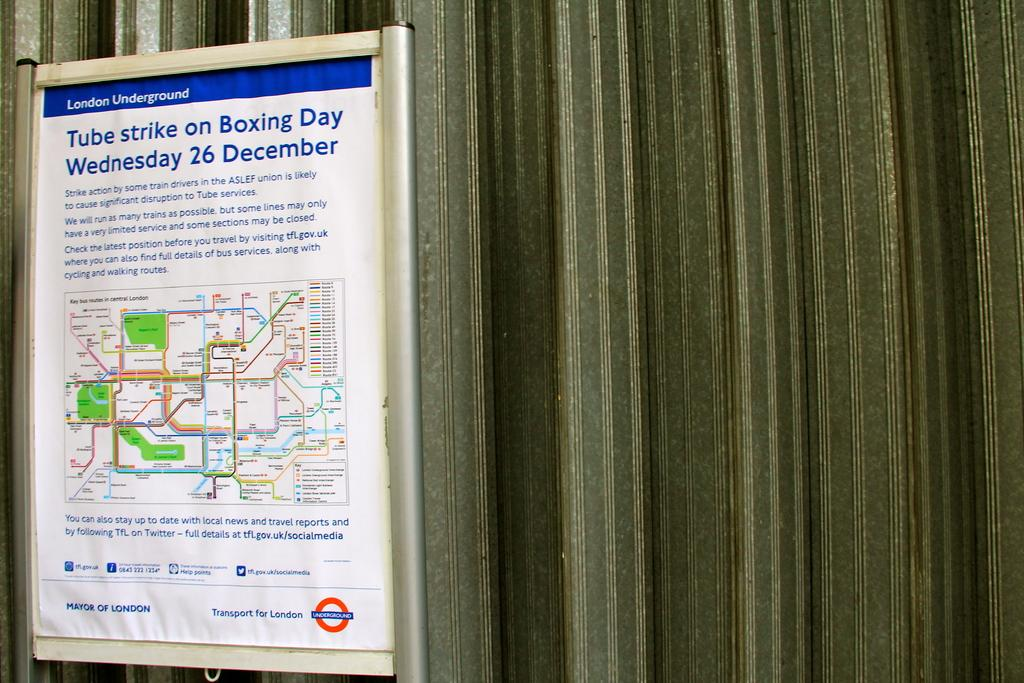<image>
Render a clear and concise summary of the photo. A sign regarding the Tube strike on Boxing Day. 